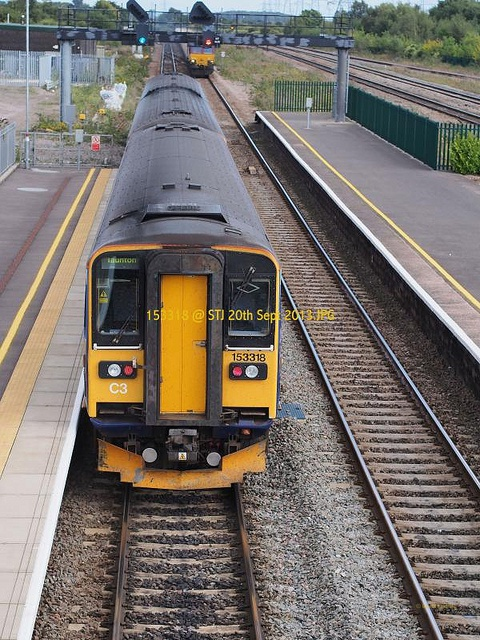Describe the objects in this image and their specific colors. I can see train in lightblue, black, gray, and orange tones and train in lightblue, black, gray, and orange tones in this image. 